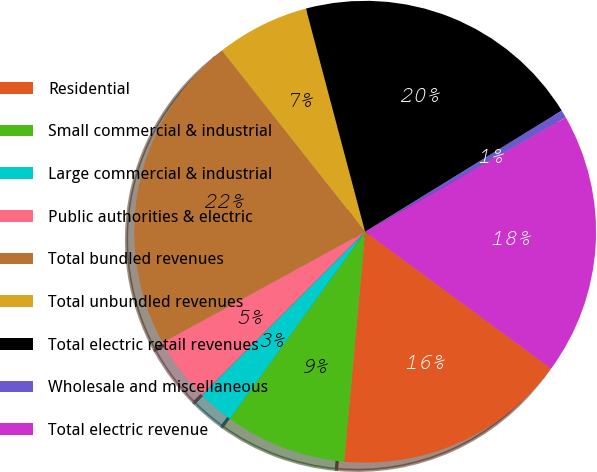<chart> <loc_0><loc_0><loc_500><loc_500><pie_chart><fcel>Residential<fcel>Small commercial & industrial<fcel>Large commercial & industrial<fcel>Public authorities & electric<fcel>Total bundled revenues<fcel>Total unbundled revenues<fcel>Total electric retail revenues<fcel>Wholesale and miscellaneous<fcel>Total electric revenue<nl><fcel>16.35%<fcel>8.51%<fcel>2.54%<fcel>4.53%<fcel>22.32%<fcel>6.52%<fcel>20.33%<fcel>0.55%<fcel>18.34%<nl></chart> 